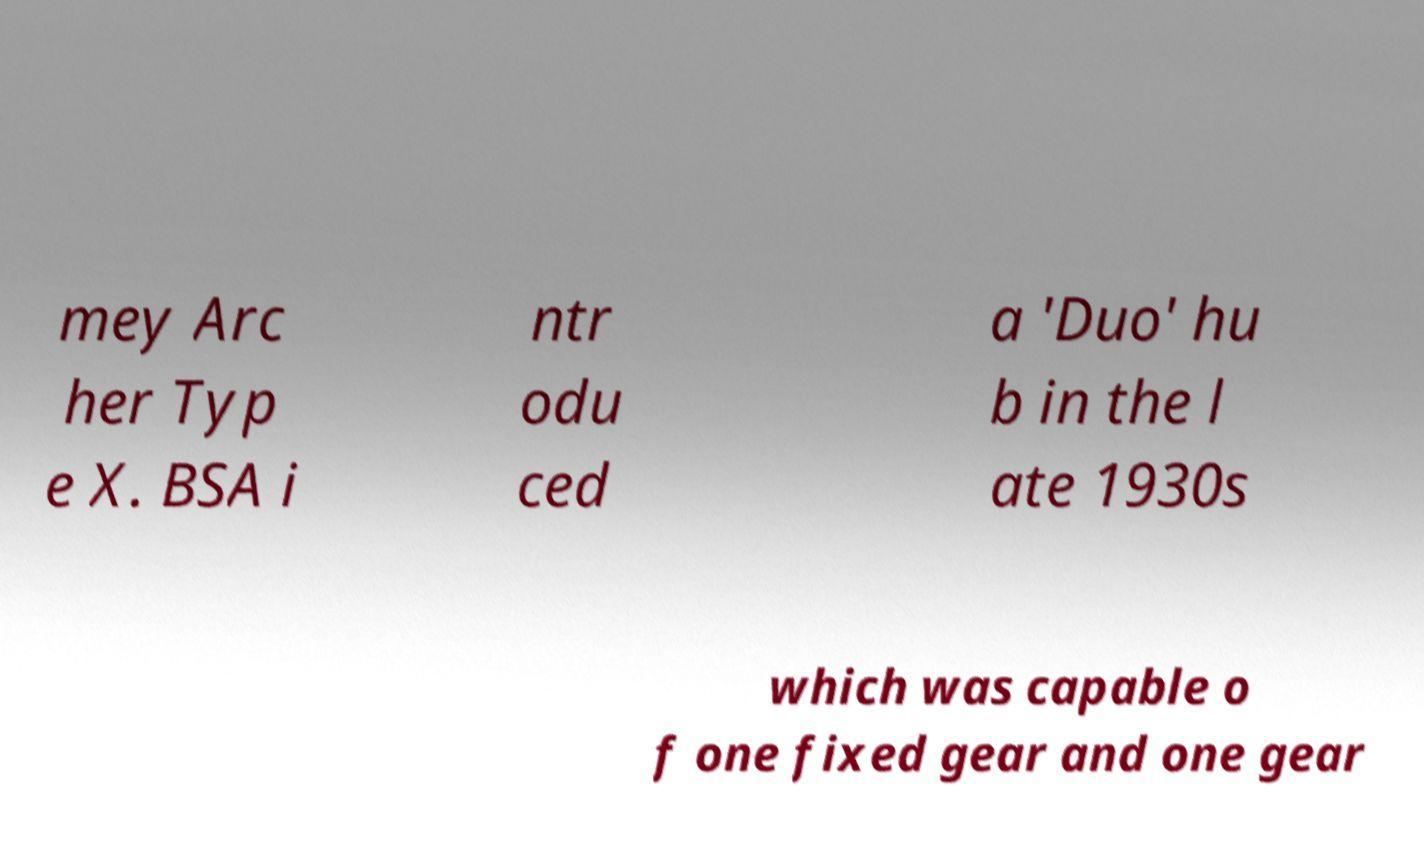For documentation purposes, I need the text within this image transcribed. Could you provide that? mey Arc her Typ e X. BSA i ntr odu ced a 'Duo' hu b in the l ate 1930s which was capable o f one fixed gear and one gear 